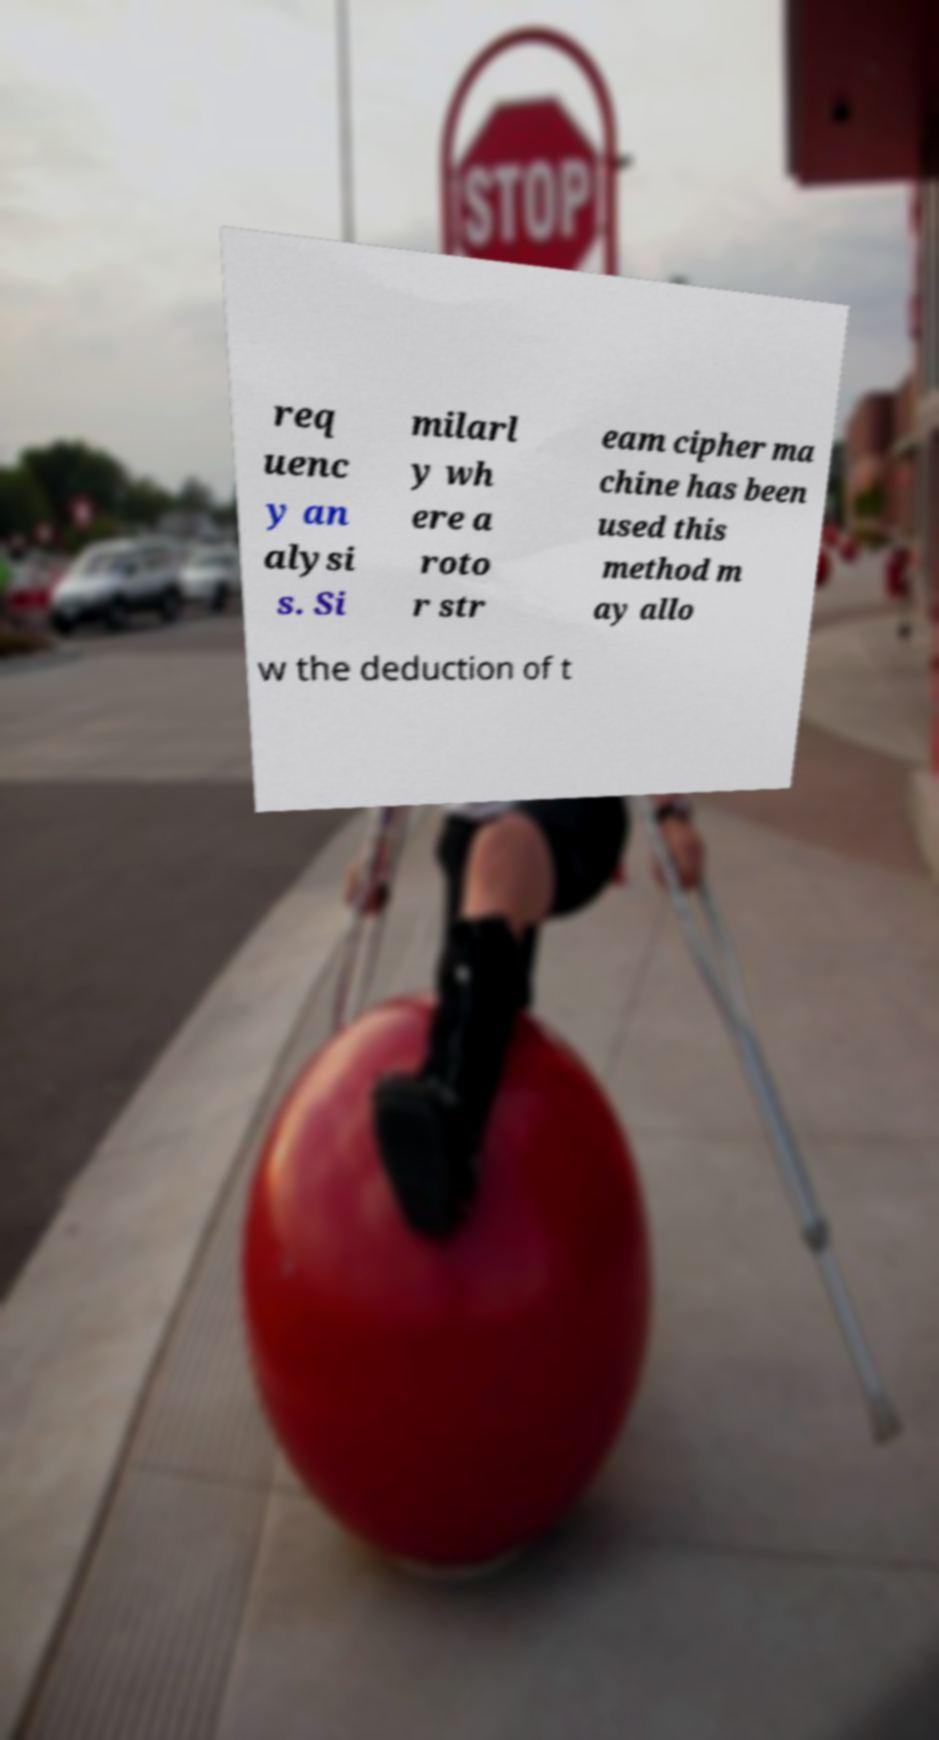Could you assist in decoding the text presented in this image and type it out clearly? req uenc y an alysi s. Si milarl y wh ere a roto r str eam cipher ma chine has been used this method m ay allo w the deduction of t 